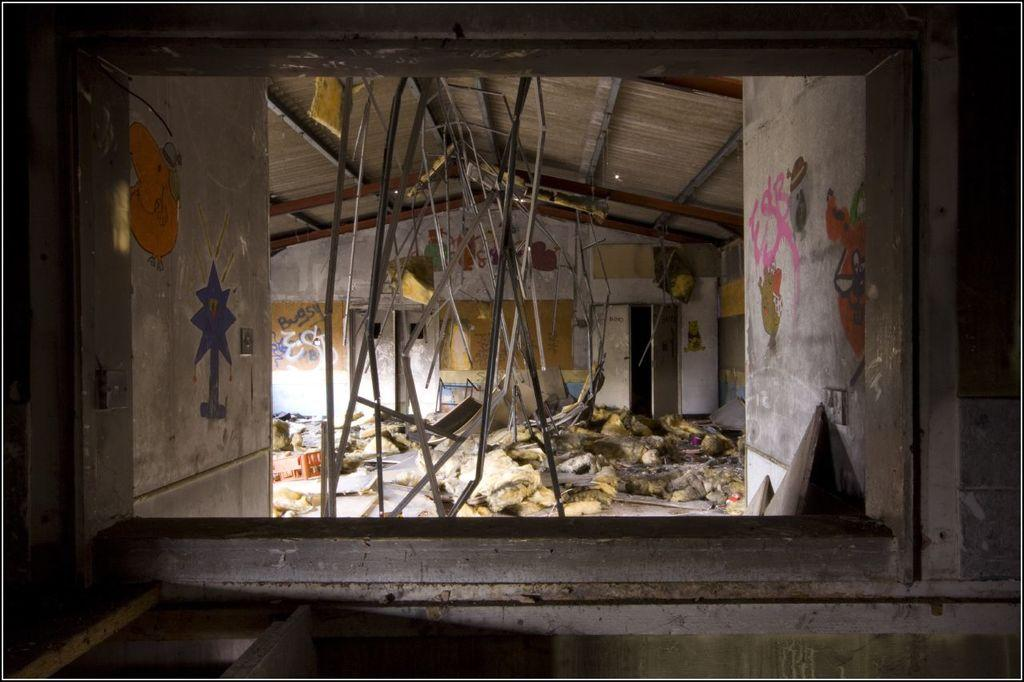What type of structure is shown in the image? The image shows an inside view of a shed. What can be seen in the middle of the shed? There is a scrap in the middle of the image. What type of slope can be seen in the image? There is no slope visible in the image; it shows an inside view of a shed with a scrap in the middle. What type of engine is present in the image? There is no engine present in the image; it shows an inside view of a shed with a scrap in the middle. 